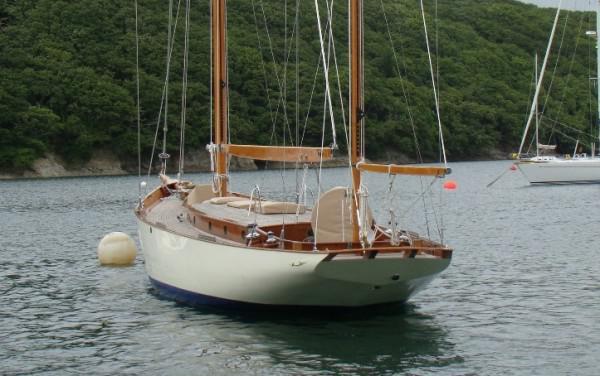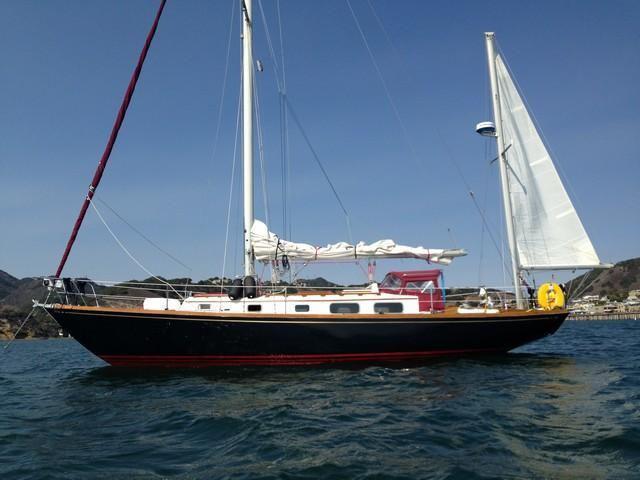The first image is the image on the left, the second image is the image on the right. Evaluate the accuracy of this statement regarding the images: "At least one white sail is up.". Is it true? Answer yes or no. Yes. The first image is the image on the left, the second image is the image on the right. Assess this claim about the two images: "A second boat is visible behind the closer boat in the image on the left.". Correct or not? Answer yes or no. Yes. 